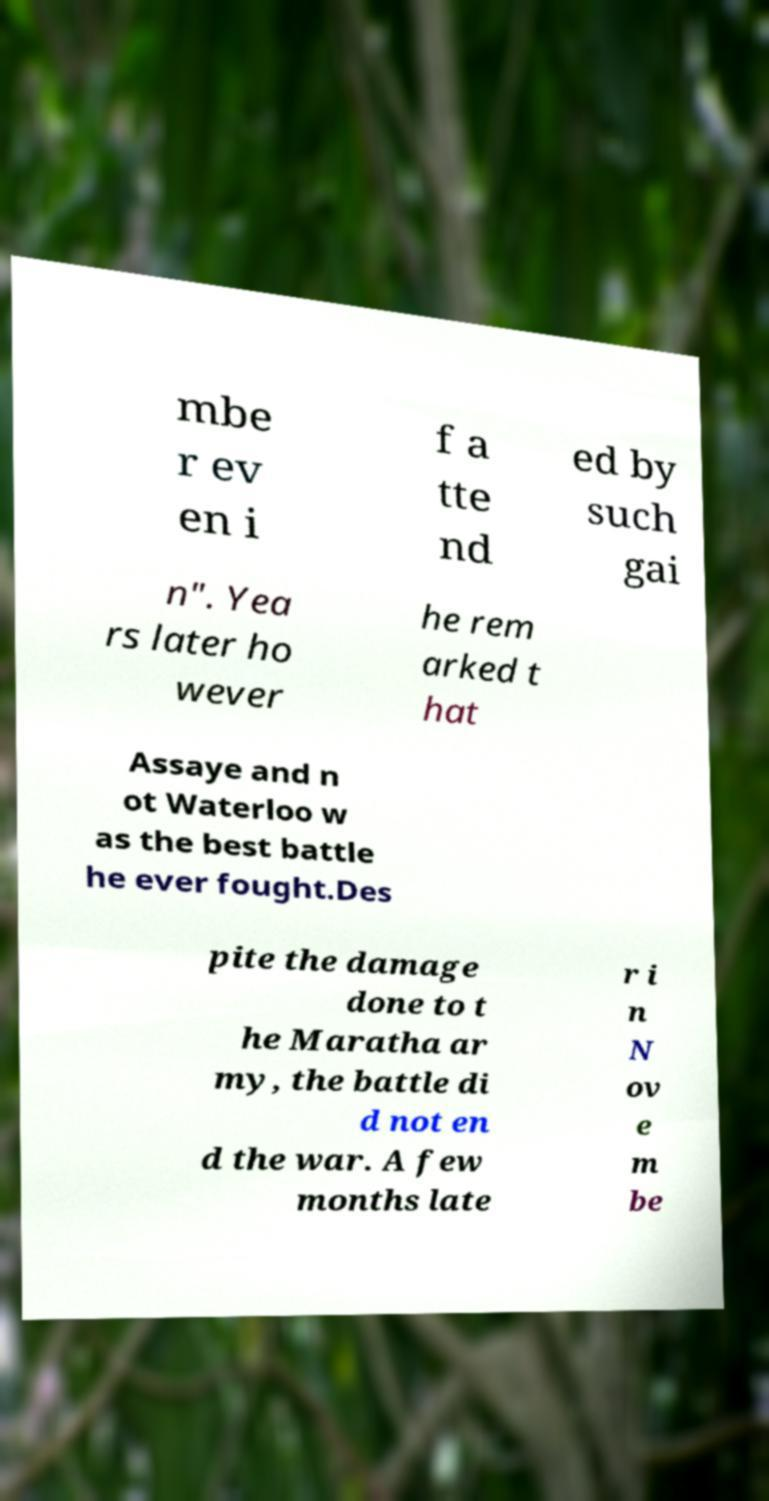Can you accurately transcribe the text from the provided image for me? mbe r ev en i f a tte nd ed by such gai n". Yea rs later ho wever he rem arked t hat Assaye and n ot Waterloo w as the best battle he ever fought.Des pite the damage done to t he Maratha ar my, the battle di d not en d the war. A few months late r i n N ov e m be 